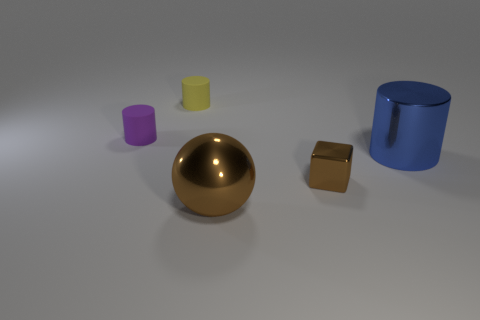Subtract all matte cylinders. How many cylinders are left? 1 Add 4 blue spheres. How many objects exist? 9 Subtract all balls. How many objects are left? 4 Add 5 metallic spheres. How many metallic spheres are left? 6 Add 3 small cyan blocks. How many small cyan blocks exist? 3 Subtract 1 brown balls. How many objects are left? 4 Subtract all small red shiny balls. Subtract all big brown objects. How many objects are left? 4 